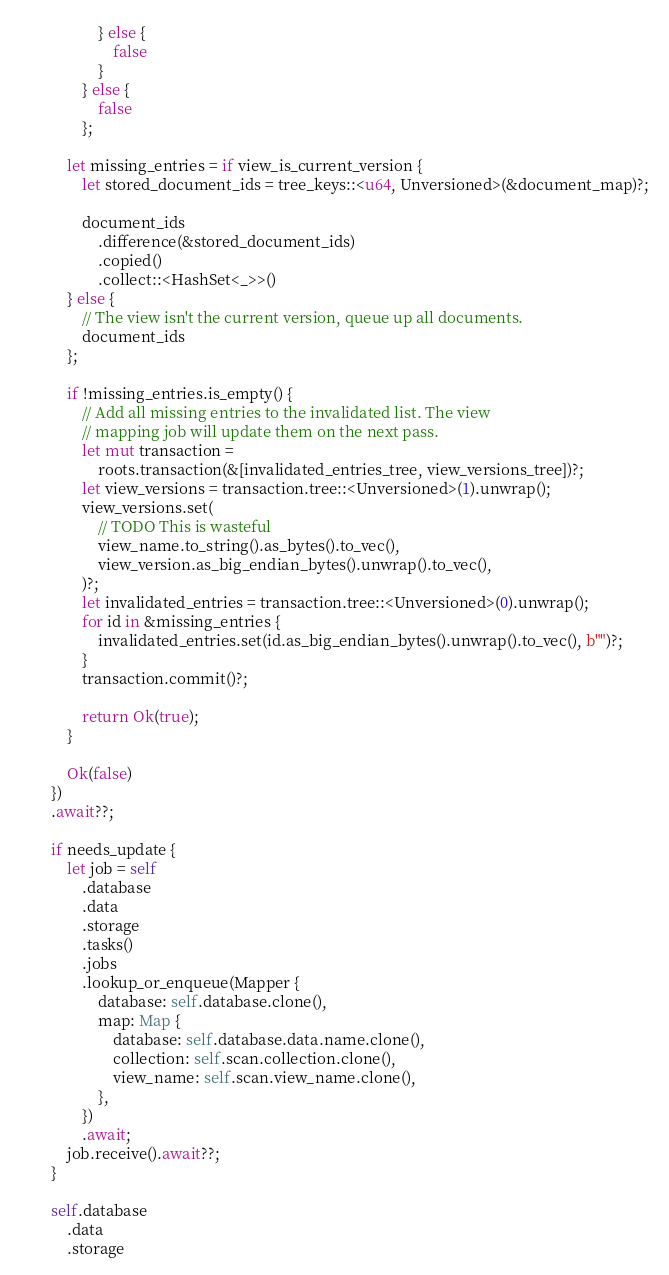Convert code to text. <code><loc_0><loc_0><loc_500><loc_500><_Rust_>                    } else {
                        false
                    }
                } else {
                    false
                };

            let missing_entries = if view_is_current_version {
                let stored_document_ids = tree_keys::<u64, Unversioned>(&document_map)?;

                document_ids
                    .difference(&stored_document_ids)
                    .copied()
                    .collect::<HashSet<_>>()
            } else {
                // The view isn't the current version, queue up all documents.
                document_ids
            };

            if !missing_entries.is_empty() {
                // Add all missing entries to the invalidated list. The view
                // mapping job will update them on the next pass.
                let mut transaction =
                    roots.transaction(&[invalidated_entries_tree, view_versions_tree])?;
                let view_versions = transaction.tree::<Unversioned>(1).unwrap();
                view_versions.set(
                    // TODO This is wasteful
                    view_name.to_string().as_bytes().to_vec(),
                    view_version.as_big_endian_bytes().unwrap().to_vec(),
                )?;
                let invalidated_entries = transaction.tree::<Unversioned>(0).unwrap();
                for id in &missing_entries {
                    invalidated_entries.set(id.as_big_endian_bytes().unwrap().to_vec(), b"")?;
                }
                transaction.commit()?;

                return Ok(true);
            }

            Ok(false)
        })
        .await??;

        if needs_update {
            let job = self
                .database
                .data
                .storage
                .tasks()
                .jobs
                .lookup_or_enqueue(Mapper {
                    database: self.database.clone(),
                    map: Map {
                        database: self.database.data.name.clone(),
                        collection: self.scan.collection.clone(),
                        view_name: self.scan.view_name.clone(),
                    },
                })
                .await;
            job.receive().await??;
        }

        self.database
            .data
            .storage</code> 